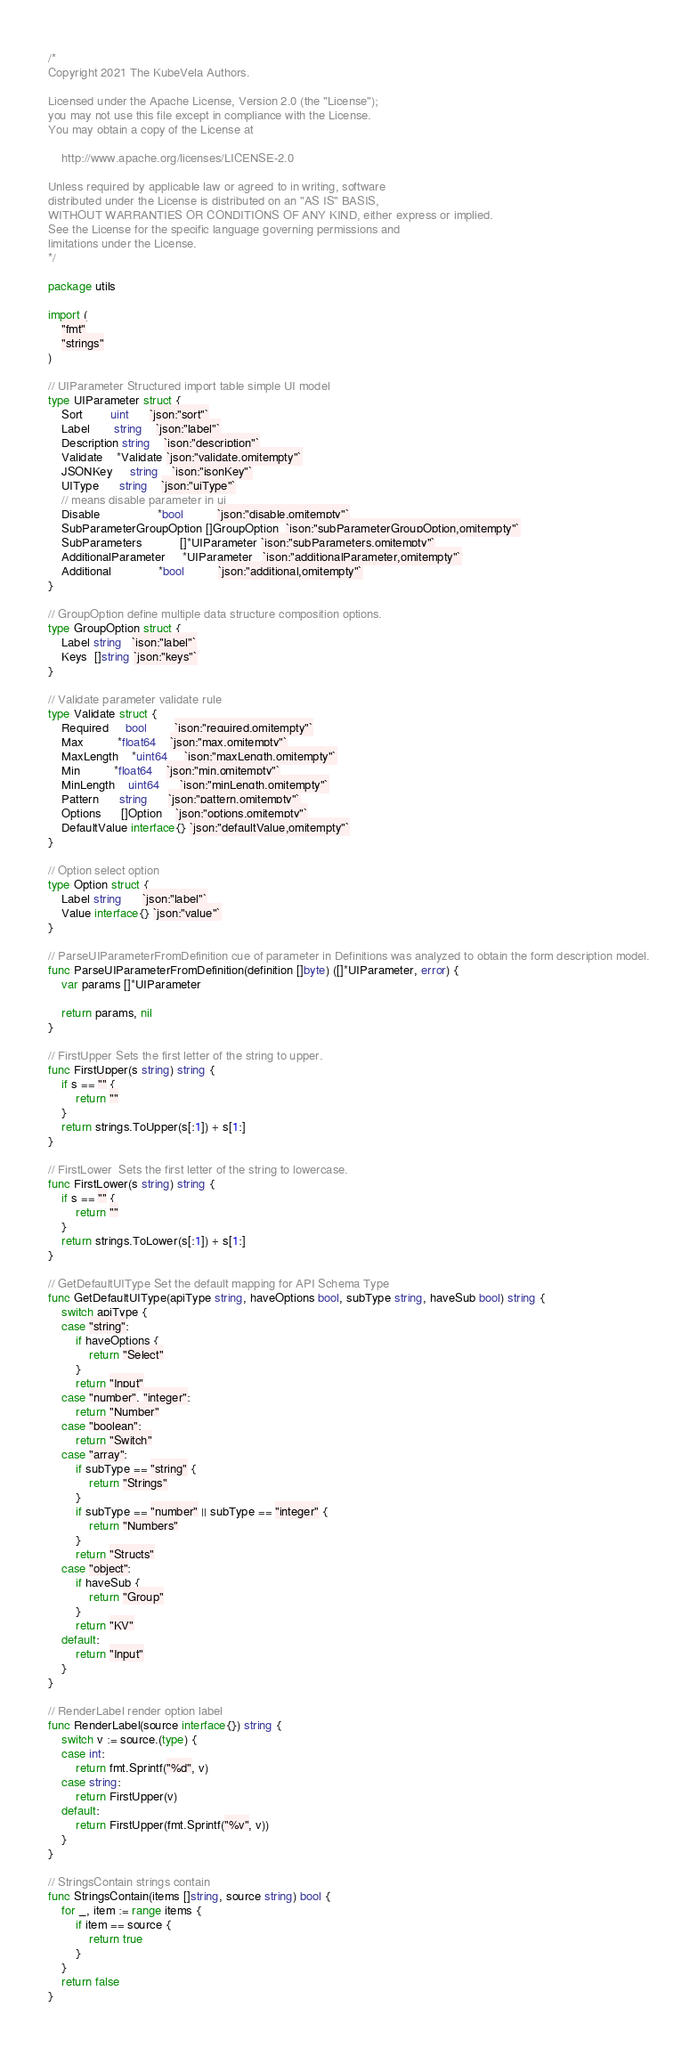<code> <loc_0><loc_0><loc_500><loc_500><_Go_>/*
Copyright 2021 The KubeVela Authors.

Licensed under the Apache License, Version 2.0 (the "License");
you may not use this file except in compliance with the License.
You may obtain a copy of the License at

	http://www.apache.org/licenses/LICENSE-2.0

Unless required by applicable law or agreed to in writing, software
distributed under the License is distributed on an "AS IS" BASIS,
WITHOUT WARRANTIES OR CONDITIONS OF ANY KIND, either express or implied.
See the License for the specific language governing permissions and
limitations under the License.
*/

package utils

import (
	"fmt"
	"strings"
)

// UIParameter Structured import table simple UI model
type UIParameter struct {
	Sort        uint      `json:"sort"`
	Label       string    `json:"label"`
	Description string    `json:"description"`
	Validate    *Validate `json:"validate,omitempty"`
	JSONKey     string    `json:"jsonKey"`
	UIType      string    `json:"uiType"`
	// means disable parameter in ui
	Disable                 *bool          `json:"disable,omitempty"`
	SubParameterGroupOption []GroupOption  `json:"subParameterGroupOption,omitempty"`
	SubParameters           []*UIParameter `json:"subParameters,omitempty"`
	AdditionalParameter     *UIParameter   `json:"additionalParameter,omitempty"`
	Additional              *bool          `json:"additional,omitempty"`
}

// GroupOption define multiple data structure composition options.
type GroupOption struct {
	Label string   `json:"label"`
	Keys  []string `json:"keys"`
}

// Validate parameter validate rule
type Validate struct {
	Required     bool        `json:"required,omitempty"`
	Max          *float64    `json:"max,omitempty"`
	MaxLength    *uint64     `json:"maxLength,omitempty"`
	Min          *float64    `json:"min,omitempty"`
	MinLength    uint64      `json:"minLength,omitempty"`
	Pattern      string      `json:"pattern,omitempty"`
	Options      []Option    `json:"options,omitempty"`
	DefaultValue interface{} `json:"defaultValue,omitempty"`
}

// Option select option
type Option struct {
	Label string      `json:"label"`
	Value interface{} `json:"value"`
}

// ParseUIParameterFromDefinition cue of parameter in Definitions was analyzed to obtain the form description model.
func ParseUIParameterFromDefinition(definition []byte) ([]*UIParameter, error) {
	var params []*UIParameter

	return params, nil
}

// FirstUpper Sets the first letter of the string to upper.
func FirstUpper(s string) string {
	if s == "" {
		return ""
	}
	return strings.ToUpper(s[:1]) + s[1:]
}

// FirstLower  Sets the first letter of the string to lowercase.
func FirstLower(s string) string {
	if s == "" {
		return ""
	}
	return strings.ToLower(s[:1]) + s[1:]
}

// GetDefaultUIType Set the default mapping for API Schema Type
func GetDefaultUIType(apiType string, haveOptions bool, subType string, haveSub bool) string {
	switch apiType {
	case "string":
		if haveOptions {
			return "Select"
		}
		return "Input"
	case "number", "integer":
		return "Number"
	case "boolean":
		return "Switch"
	case "array":
		if subType == "string" {
			return "Strings"
		}
		if subType == "number" || subType == "integer" {
			return "Numbers"
		}
		return "Structs"
	case "object":
		if haveSub {
			return "Group"
		}
		return "KV"
	default:
		return "Input"
	}
}

// RenderLabel render option label
func RenderLabel(source interface{}) string {
	switch v := source.(type) {
	case int:
		return fmt.Sprintf("%d", v)
	case string:
		return FirstUpper(v)
	default:
		return FirstUpper(fmt.Sprintf("%v", v))
	}
}

// StringsContain strings contain
func StringsContain(items []string, source string) bool {
	for _, item := range items {
		if item == source {
			return true
		}
	}
	return false
}
</code> 